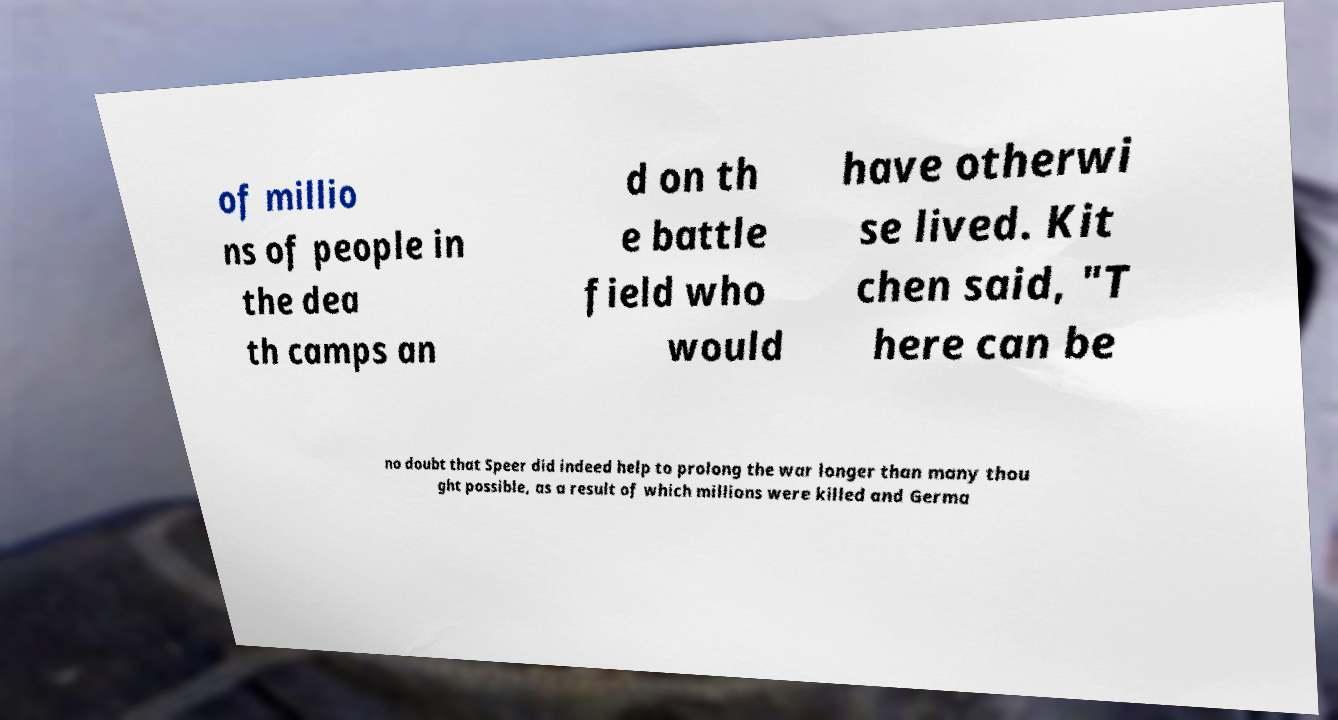I need the written content from this picture converted into text. Can you do that? of millio ns of people in the dea th camps an d on th e battle field who would have otherwi se lived. Kit chen said, "T here can be no doubt that Speer did indeed help to prolong the war longer than many thou ght possible, as a result of which millions were killed and Germa 